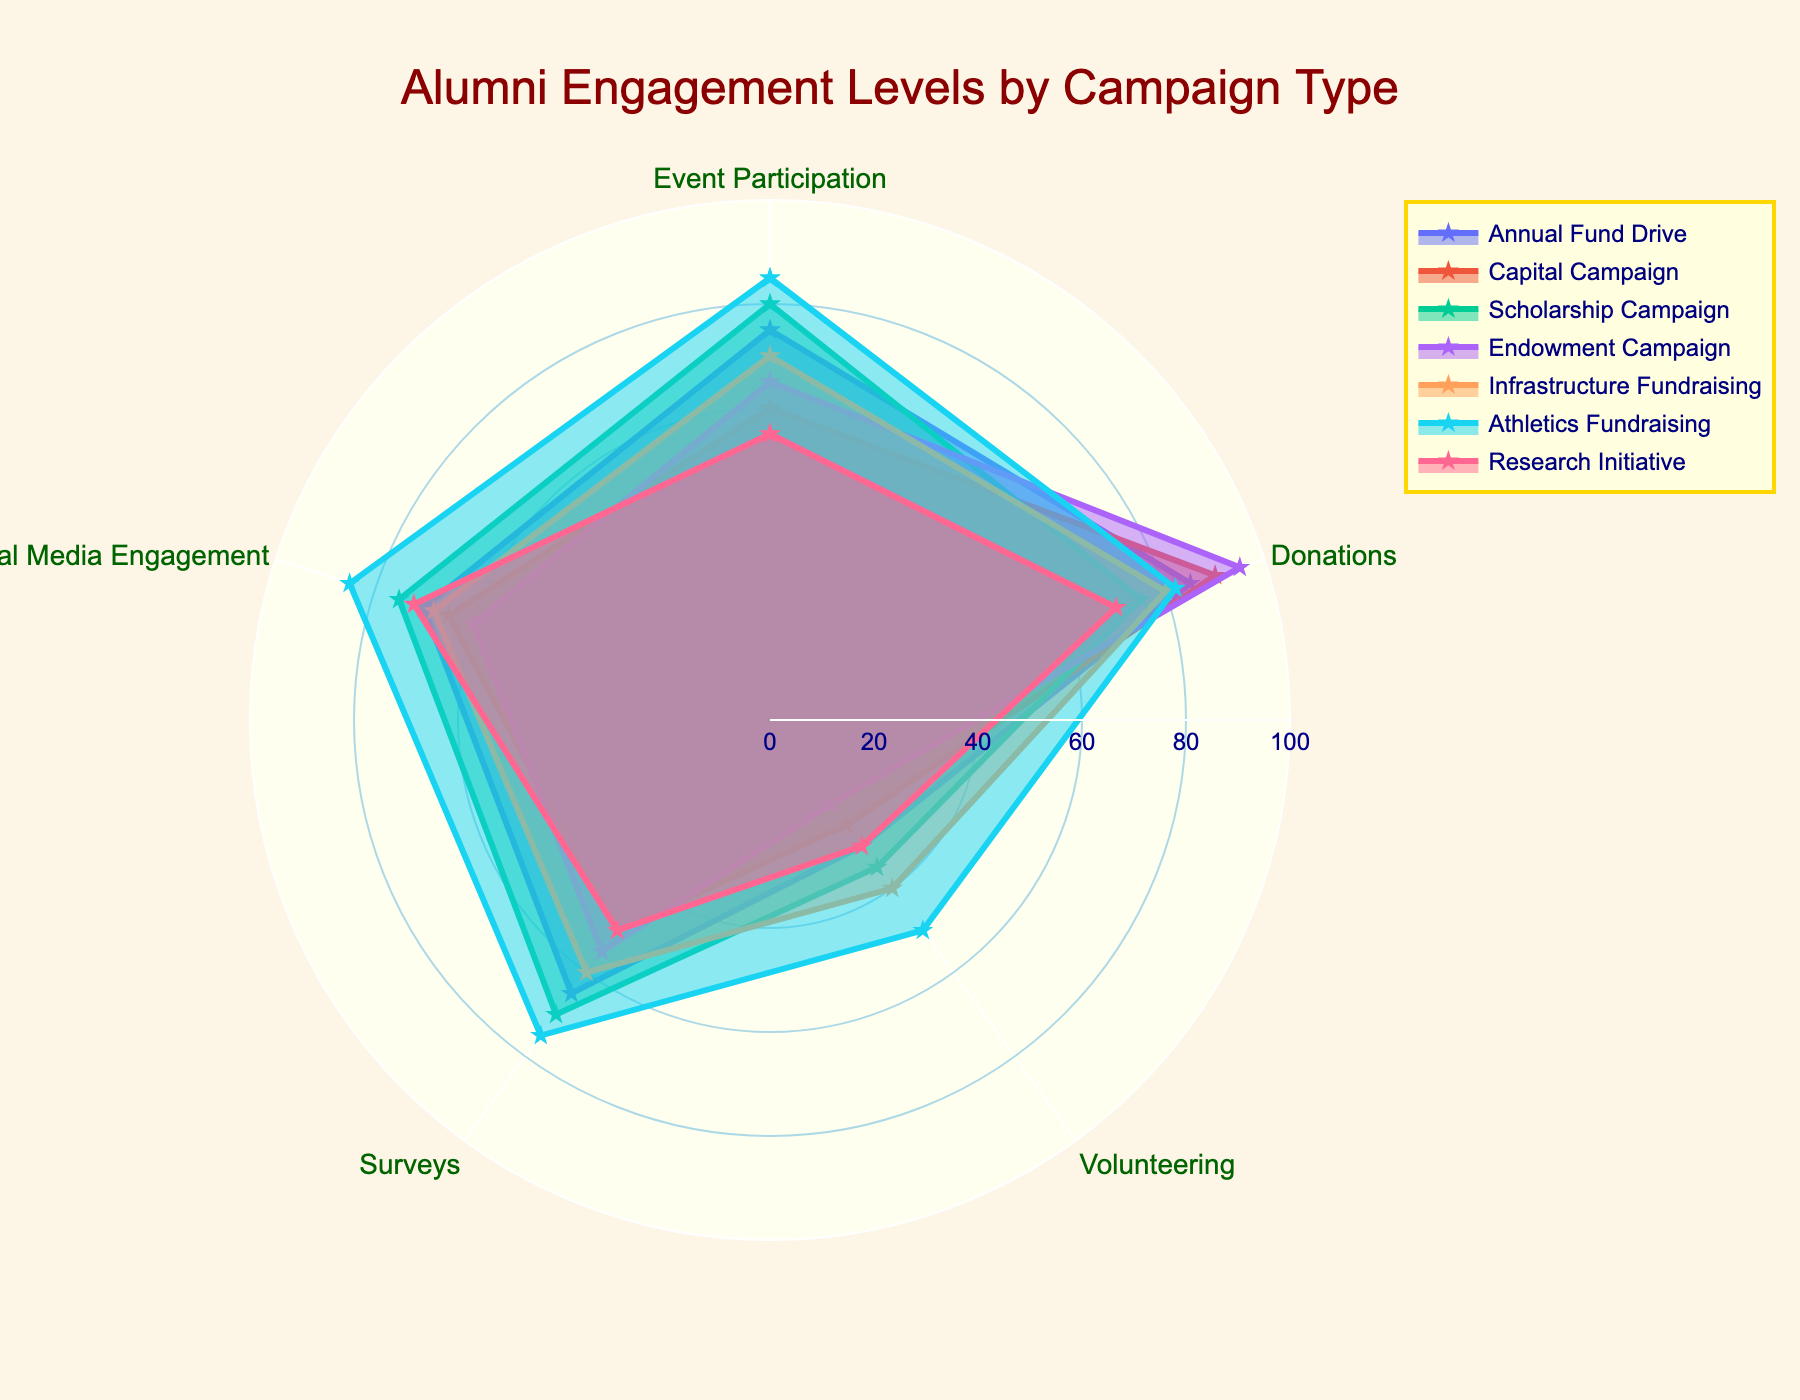How many campaign types are displayed in the radar chart? Count the number of unique campaign types shown in the figure. There are 7 unique campaign types: Annual Fund Drive, Capital Campaign, Scholarship Campaign, Endowment Campaign, Infrastructure Fundraising, Athletics Fundraising, and Research Initiative.
Answer: 7 What is the title of the radar chart? Look at the title text displayed prominently at the top of the figure. The title is "Alumni Engagement Levels by Campaign Type".
Answer: Alumni Engagement Levels by Campaign Type Which campaign type has the highest level of Donations? Compare the values of Donations for each campaign type and identify the highest value. The Endowment Campaign has the highest Donations level of 95.
Answer: Endowment Campaign Which two campaign types have the biggest difference in Event Participation levels? Calculate the difference in Event Participation levels for all pairs of campaign types and identify the two with the largest difference. Athletics Fundraising has 85, and Research Initiative has 55. The difference is 85 - 55 = 30.
Answer: Athletics Fundraising, Research Initiative What is the average level of Social Media Engagement across all campaign types? Add up the Social Media Engagement levels for all campaign types and divide by the number of campaign types. (70 + 65 + 75 + 60 + 68 + 85 + 72) / 7 = 495 / 7 = 70.71
Answer: 70.71 Which campaign type has the lowest Volunteering level and what is the value? Check the Volunteering levels for each campaign type and identify the lowest value. The Endowment Campaign has the lowest Volunteering level of 20.
Answer: Endowment Campaign, 20 Between the Annual Fund Drive and Scholarship Campaign, which has higher Survey participation? Compare the Survey participation values of these two campaign types. Annual Fund Drive has 65, while Scholarship Campaign has 70. Scholarship Campaign is higher.
Answer: Scholarship Campaign How many different engagement metrics are presented per campaign type? Count the number of unique engagement metrics shown for each campaign type. The metrics are Event Participation, Donations, Volunteering, Surveys, and Social Media Engagement. There are 5 metrics.
Answer: 5 What is the range of the Donations levels across all campaign types? Identify the minimum and maximum values of Donations levels and calculate the difference. The minimum is 70 (Research Initiative) and the maximum is 95 (Endowment Campaign). The range is 95 - 70 = 25.
Answer: 25 Which campaign shows the fullest polygon (most balanced engagement) and what are the levels for each metric? Visually inspect the consistency of the engagement levels across all metrics for each campaign type, and identify the one with the least variation. The Athletics Fundraising campaign appears to be the most balanced, with 85 (Event Participation), 82 (Donations), 50 (Volunteering), 75 (Surveys), and 85 (Social Media Engagement).
Answer: Athletics Fundraising, 85 (Event Participation), 82 (Donations), 50 (Volunteering), 75 (Surveys), 85 (Social Media Engagement) 